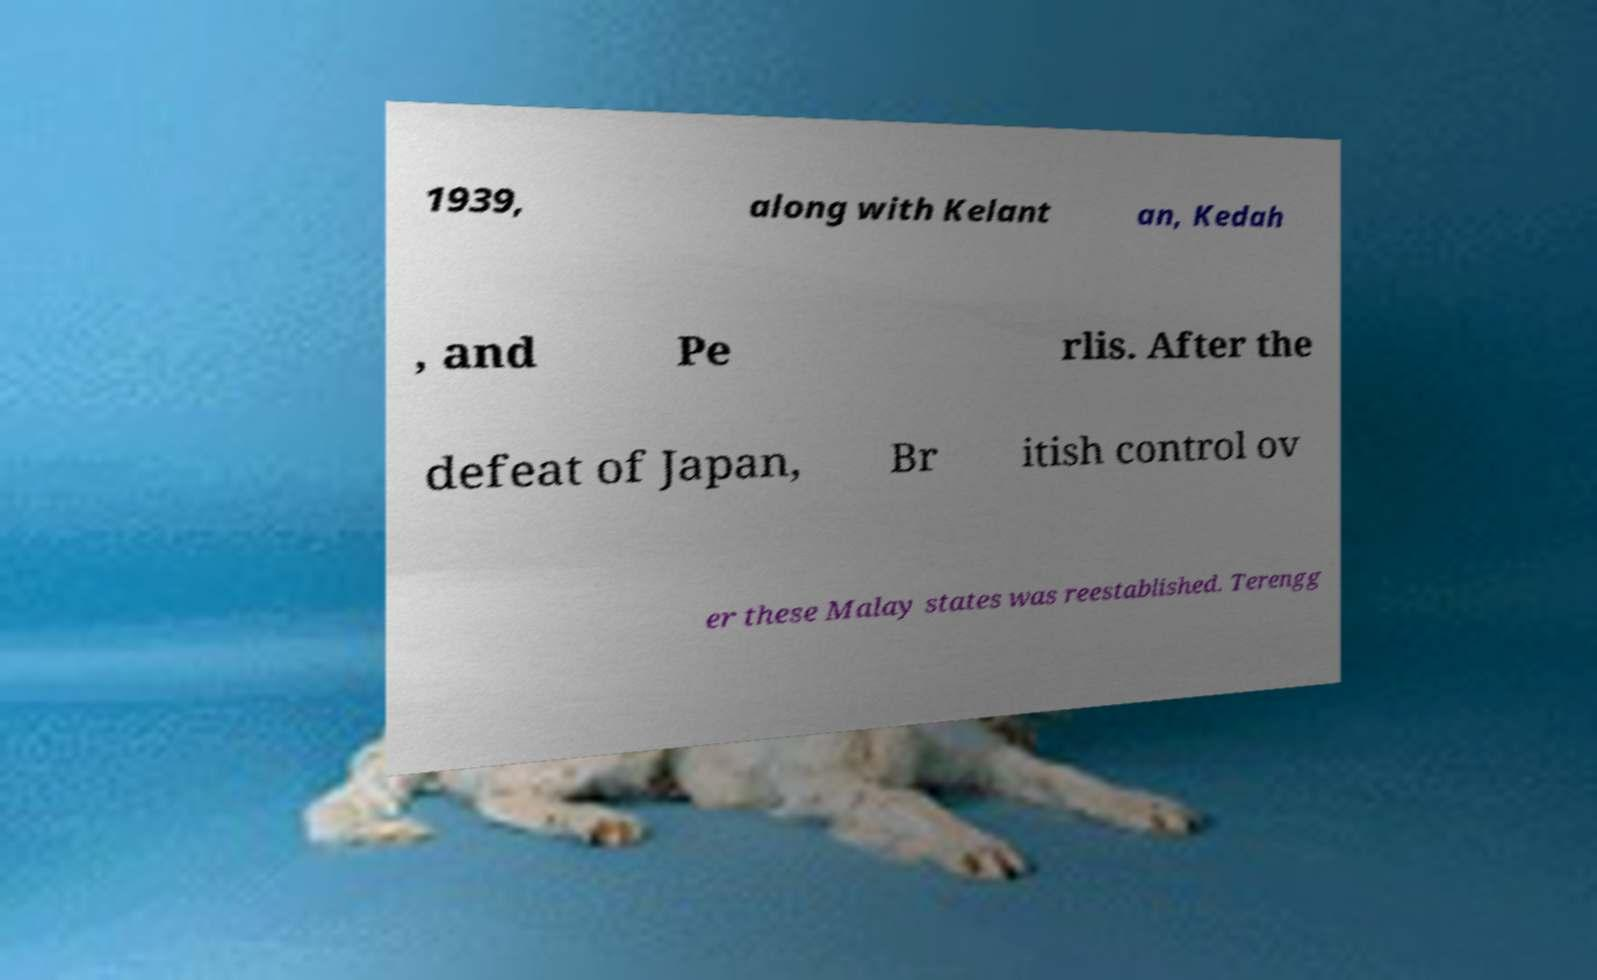For documentation purposes, I need the text within this image transcribed. Could you provide that? 1939, along with Kelant an, Kedah , and Pe rlis. After the defeat of Japan, Br itish control ov er these Malay states was reestablished. Terengg 